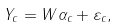Convert formula to latex. <formula><loc_0><loc_0><loc_500><loc_500>Y _ { c } = W \alpha _ { c } + \varepsilon _ { c } ,</formula> 